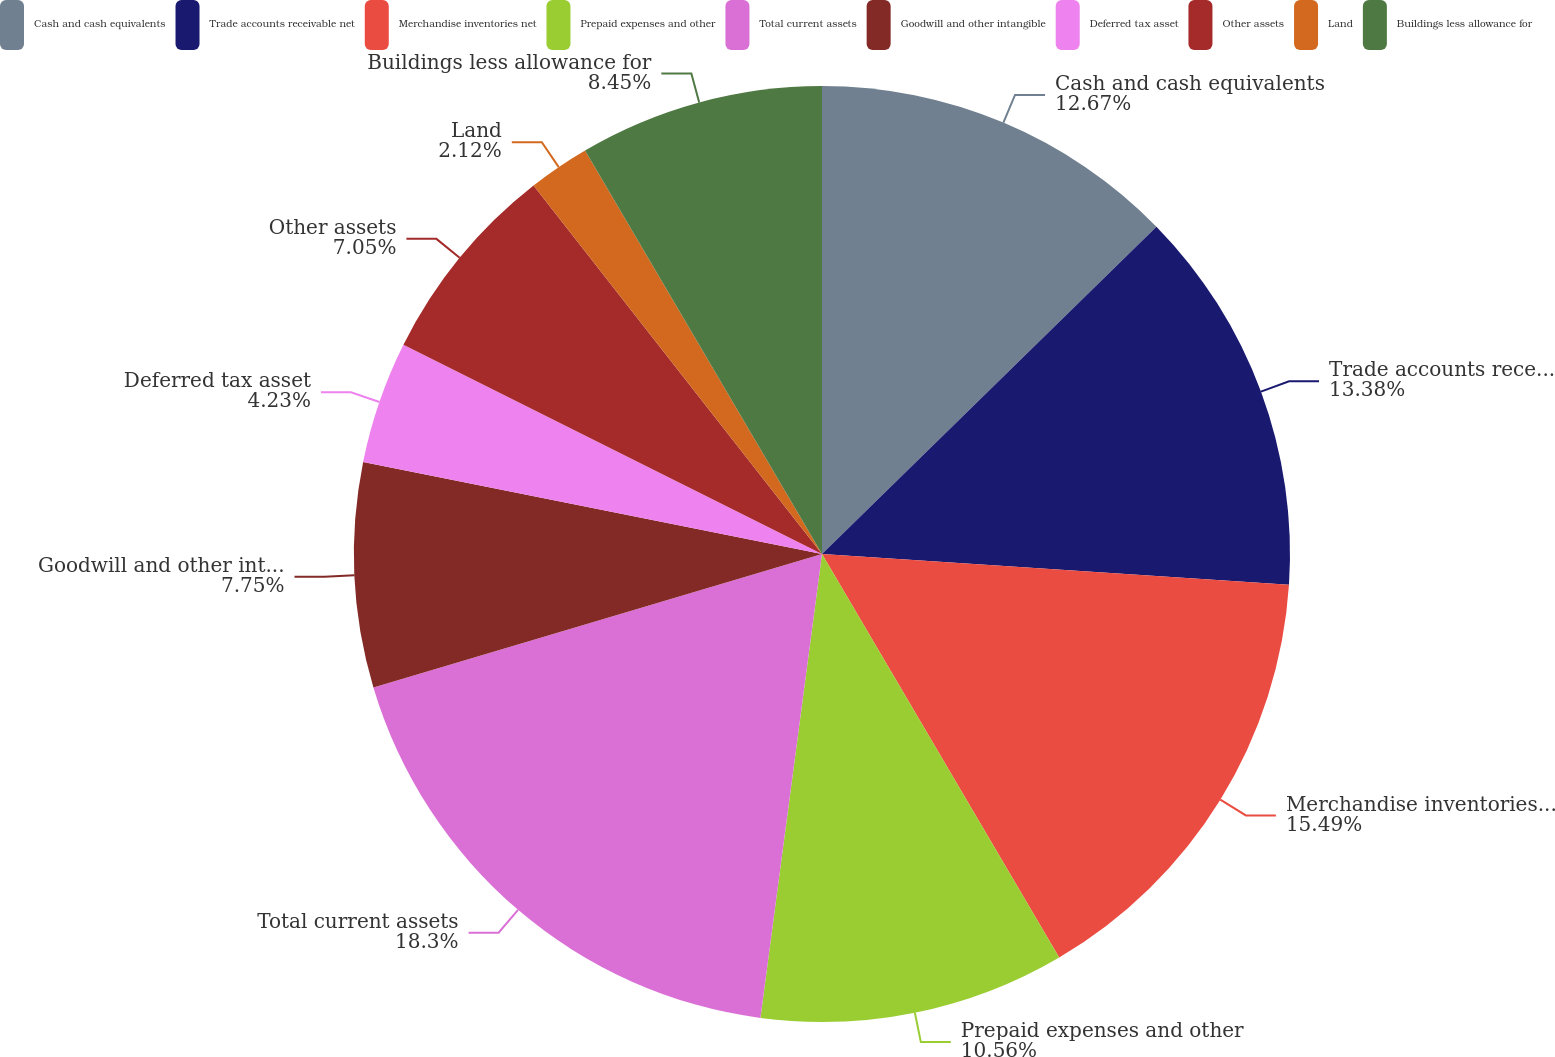<chart> <loc_0><loc_0><loc_500><loc_500><pie_chart><fcel>Cash and cash equivalents<fcel>Trade accounts receivable net<fcel>Merchandise inventories net<fcel>Prepaid expenses and other<fcel>Total current assets<fcel>Goodwill and other intangible<fcel>Deferred tax asset<fcel>Other assets<fcel>Land<fcel>Buildings less allowance for<nl><fcel>12.67%<fcel>13.38%<fcel>15.49%<fcel>10.56%<fcel>18.3%<fcel>7.75%<fcel>4.23%<fcel>7.05%<fcel>2.12%<fcel>8.45%<nl></chart> 